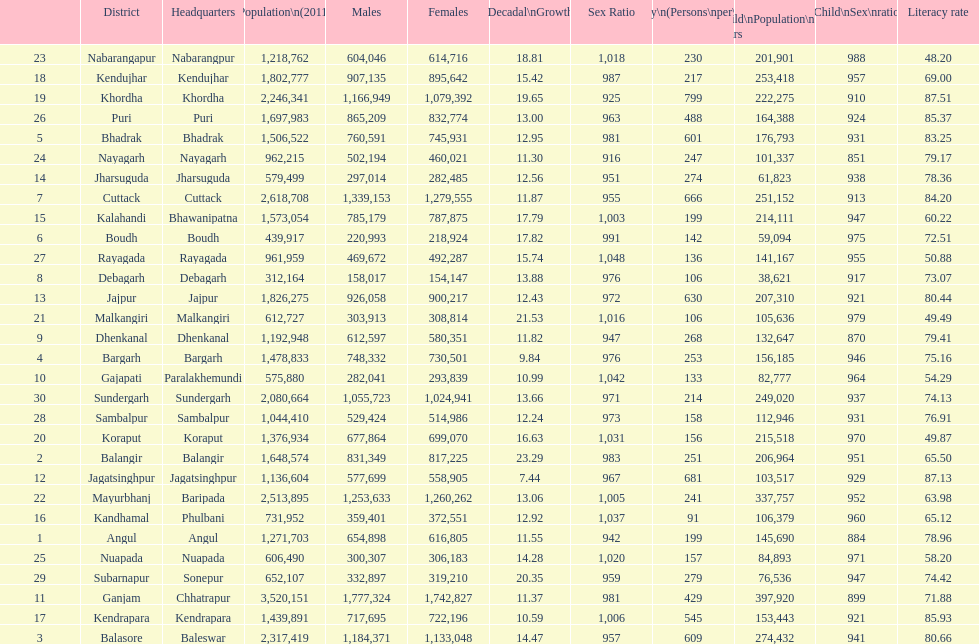How many females live in cuttack? 1,279,555. 